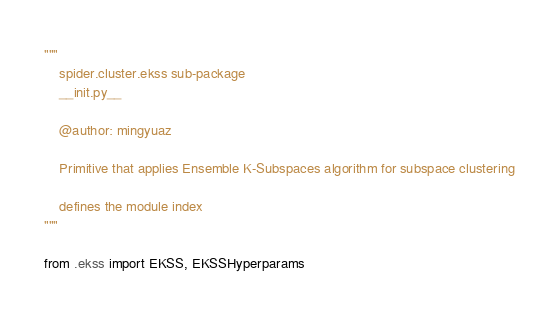Convert code to text. <code><loc_0><loc_0><loc_500><loc_500><_Python_>"""
    spider.cluster.ekss sub-package
    __init.py__

    @author: mingyuaz

    Primitive that applies Ensemble K-Subspaces algorithm for subspace clustering

    defines the module index
"""

from .ekss import EKSS, EKSSHyperparams
</code> 